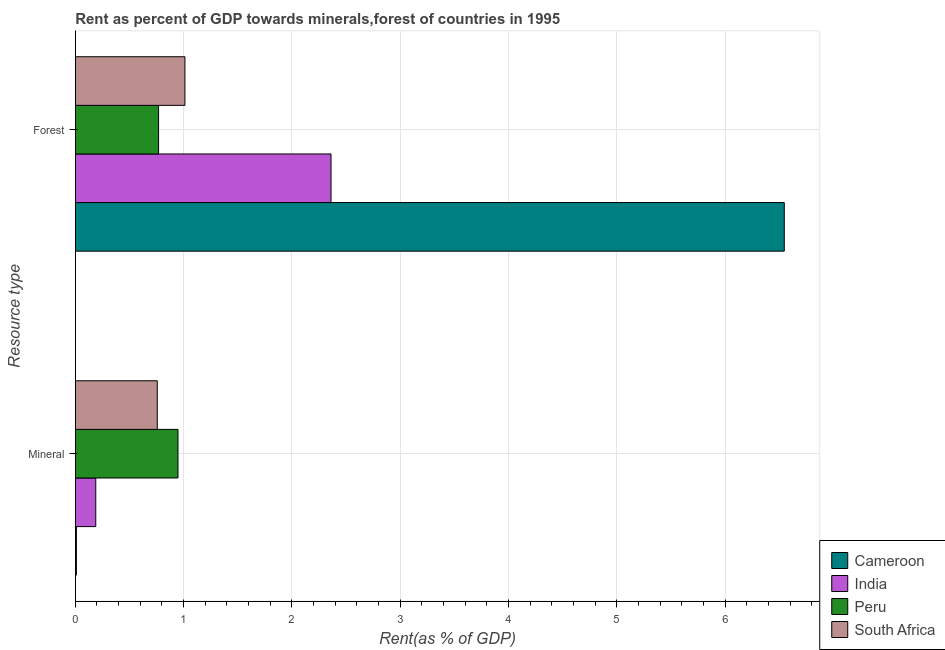How many different coloured bars are there?
Provide a succinct answer. 4. How many groups of bars are there?
Give a very brief answer. 2. Are the number of bars per tick equal to the number of legend labels?
Ensure brevity in your answer.  Yes. Are the number of bars on each tick of the Y-axis equal?
Offer a very short reply. Yes. How many bars are there on the 2nd tick from the bottom?
Make the answer very short. 4. What is the label of the 2nd group of bars from the top?
Keep it short and to the point. Mineral. What is the mineral rent in Peru?
Your answer should be very brief. 0.95. Across all countries, what is the maximum mineral rent?
Ensure brevity in your answer.  0.95. Across all countries, what is the minimum forest rent?
Give a very brief answer. 0.77. In which country was the forest rent maximum?
Make the answer very short. Cameroon. What is the total forest rent in the graph?
Your response must be concise. 10.69. What is the difference between the mineral rent in Cameroon and that in India?
Give a very brief answer. -0.18. What is the difference between the mineral rent in Cameroon and the forest rent in Peru?
Keep it short and to the point. -0.76. What is the average mineral rent per country?
Provide a short and direct response. 0.48. What is the difference between the forest rent and mineral rent in India?
Offer a very short reply. 2.17. In how many countries, is the mineral rent greater than 1.8 %?
Provide a succinct answer. 0. What is the ratio of the mineral rent in Cameroon to that in India?
Make the answer very short. 0.05. Is the forest rent in Peru less than that in South Africa?
Give a very brief answer. Yes. In how many countries, is the forest rent greater than the average forest rent taken over all countries?
Your answer should be very brief. 1. What does the 1st bar from the top in Forest represents?
Offer a very short reply. South Africa. Are all the bars in the graph horizontal?
Provide a succinct answer. Yes. How many countries are there in the graph?
Provide a succinct answer. 4. What is the difference between two consecutive major ticks on the X-axis?
Offer a very short reply. 1. Are the values on the major ticks of X-axis written in scientific E-notation?
Provide a succinct answer. No. Does the graph contain any zero values?
Provide a succinct answer. No. Does the graph contain grids?
Your response must be concise. Yes. Where does the legend appear in the graph?
Ensure brevity in your answer.  Bottom right. How many legend labels are there?
Provide a succinct answer. 4. How are the legend labels stacked?
Provide a short and direct response. Vertical. What is the title of the graph?
Your answer should be very brief. Rent as percent of GDP towards minerals,forest of countries in 1995. What is the label or title of the X-axis?
Keep it short and to the point. Rent(as % of GDP). What is the label or title of the Y-axis?
Keep it short and to the point. Resource type. What is the Rent(as % of GDP) in Cameroon in Mineral?
Your answer should be very brief. 0.01. What is the Rent(as % of GDP) of India in Mineral?
Make the answer very short. 0.19. What is the Rent(as % of GDP) of Peru in Mineral?
Your response must be concise. 0.95. What is the Rent(as % of GDP) in South Africa in Mineral?
Your answer should be compact. 0.76. What is the Rent(as % of GDP) of Cameroon in Forest?
Your response must be concise. 6.55. What is the Rent(as % of GDP) of India in Forest?
Ensure brevity in your answer.  2.36. What is the Rent(as % of GDP) of Peru in Forest?
Provide a succinct answer. 0.77. What is the Rent(as % of GDP) of South Africa in Forest?
Keep it short and to the point. 1.01. Across all Resource type, what is the maximum Rent(as % of GDP) in Cameroon?
Provide a short and direct response. 6.55. Across all Resource type, what is the maximum Rent(as % of GDP) of India?
Give a very brief answer. 2.36. Across all Resource type, what is the maximum Rent(as % of GDP) of Peru?
Provide a short and direct response. 0.95. Across all Resource type, what is the maximum Rent(as % of GDP) of South Africa?
Your answer should be very brief. 1.01. Across all Resource type, what is the minimum Rent(as % of GDP) in Cameroon?
Your answer should be very brief. 0.01. Across all Resource type, what is the minimum Rent(as % of GDP) of India?
Provide a short and direct response. 0.19. Across all Resource type, what is the minimum Rent(as % of GDP) in Peru?
Your answer should be compact. 0.77. Across all Resource type, what is the minimum Rent(as % of GDP) of South Africa?
Provide a succinct answer. 0.76. What is the total Rent(as % of GDP) in Cameroon in the graph?
Your answer should be compact. 6.56. What is the total Rent(as % of GDP) in India in the graph?
Make the answer very short. 2.55. What is the total Rent(as % of GDP) of Peru in the graph?
Your response must be concise. 1.72. What is the total Rent(as % of GDP) of South Africa in the graph?
Give a very brief answer. 1.77. What is the difference between the Rent(as % of GDP) of Cameroon in Mineral and that in Forest?
Offer a very short reply. -6.54. What is the difference between the Rent(as % of GDP) of India in Mineral and that in Forest?
Offer a terse response. -2.17. What is the difference between the Rent(as % of GDP) of Peru in Mineral and that in Forest?
Ensure brevity in your answer.  0.18. What is the difference between the Rent(as % of GDP) of South Africa in Mineral and that in Forest?
Offer a very short reply. -0.26. What is the difference between the Rent(as % of GDP) in Cameroon in Mineral and the Rent(as % of GDP) in India in Forest?
Your answer should be very brief. -2.35. What is the difference between the Rent(as % of GDP) in Cameroon in Mineral and the Rent(as % of GDP) in Peru in Forest?
Provide a succinct answer. -0.76. What is the difference between the Rent(as % of GDP) of Cameroon in Mineral and the Rent(as % of GDP) of South Africa in Forest?
Your answer should be very brief. -1. What is the difference between the Rent(as % of GDP) in India in Mineral and the Rent(as % of GDP) in Peru in Forest?
Your answer should be compact. -0.58. What is the difference between the Rent(as % of GDP) of India in Mineral and the Rent(as % of GDP) of South Africa in Forest?
Give a very brief answer. -0.82. What is the difference between the Rent(as % of GDP) of Peru in Mineral and the Rent(as % of GDP) of South Africa in Forest?
Give a very brief answer. -0.06. What is the average Rent(as % of GDP) in Cameroon per Resource type?
Your response must be concise. 3.28. What is the average Rent(as % of GDP) of India per Resource type?
Offer a terse response. 1.28. What is the average Rent(as % of GDP) in Peru per Resource type?
Provide a short and direct response. 0.86. What is the average Rent(as % of GDP) of South Africa per Resource type?
Your response must be concise. 0.88. What is the difference between the Rent(as % of GDP) of Cameroon and Rent(as % of GDP) of India in Mineral?
Keep it short and to the point. -0.18. What is the difference between the Rent(as % of GDP) in Cameroon and Rent(as % of GDP) in Peru in Mineral?
Your answer should be very brief. -0.94. What is the difference between the Rent(as % of GDP) in Cameroon and Rent(as % of GDP) in South Africa in Mineral?
Keep it short and to the point. -0.75. What is the difference between the Rent(as % of GDP) in India and Rent(as % of GDP) in Peru in Mineral?
Keep it short and to the point. -0.76. What is the difference between the Rent(as % of GDP) in India and Rent(as % of GDP) in South Africa in Mineral?
Offer a very short reply. -0.57. What is the difference between the Rent(as % of GDP) in Peru and Rent(as % of GDP) in South Africa in Mineral?
Keep it short and to the point. 0.19. What is the difference between the Rent(as % of GDP) of Cameroon and Rent(as % of GDP) of India in Forest?
Ensure brevity in your answer.  4.19. What is the difference between the Rent(as % of GDP) in Cameroon and Rent(as % of GDP) in Peru in Forest?
Provide a succinct answer. 5.78. What is the difference between the Rent(as % of GDP) of Cameroon and Rent(as % of GDP) of South Africa in Forest?
Your answer should be compact. 5.53. What is the difference between the Rent(as % of GDP) in India and Rent(as % of GDP) in Peru in Forest?
Provide a succinct answer. 1.59. What is the difference between the Rent(as % of GDP) of India and Rent(as % of GDP) of South Africa in Forest?
Provide a succinct answer. 1.35. What is the difference between the Rent(as % of GDP) of Peru and Rent(as % of GDP) of South Africa in Forest?
Give a very brief answer. -0.24. What is the ratio of the Rent(as % of GDP) in Cameroon in Mineral to that in Forest?
Give a very brief answer. 0. What is the ratio of the Rent(as % of GDP) in India in Mineral to that in Forest?
Offer a terse response. 0.08. What is the ratio of the Rent(as % of GDP) in Peru in Mineral to that in Forest?
Ensure brevity in your answer.  1.23. What is the ratio of the Rent(as % of GDP) of South Africa in Mineral to that in Forest?
Provide a short and direct response. 0.75. What is the difference between the highest and the second highest Rent(as % of GDP) of Cameroon?
Your answer should be compact. 6.54. What is the difference between the highest and the second highest Rent(as % of GDP) of India?
Offer a very short reply. 2.17. What is the difference between the highest and the second highest Rent(as % of GDP) of Peru?
Your response must be concise. 0.18. What is the difference between the highest and the second highest Rent(as % of GDP) of South Africa?
Keep it short and to the point. 0.26. What is the difference between the highest and the lowest Rent(as % of GDP) of Cameroon?
Keep it short and to the point. 6.54. What is the difference between the highest and the lowest Rent(as % of GDP) in India?
Make the answer very short. 2.17. What is the difference between the highest and the lowest Rent(as % of GDP) of Peru?
Offer a very short reply. 0.18. What is the difference between the highest and the lowest Rent(as % of GDP) of South Africa?
Offer a terse response. 0.26. 